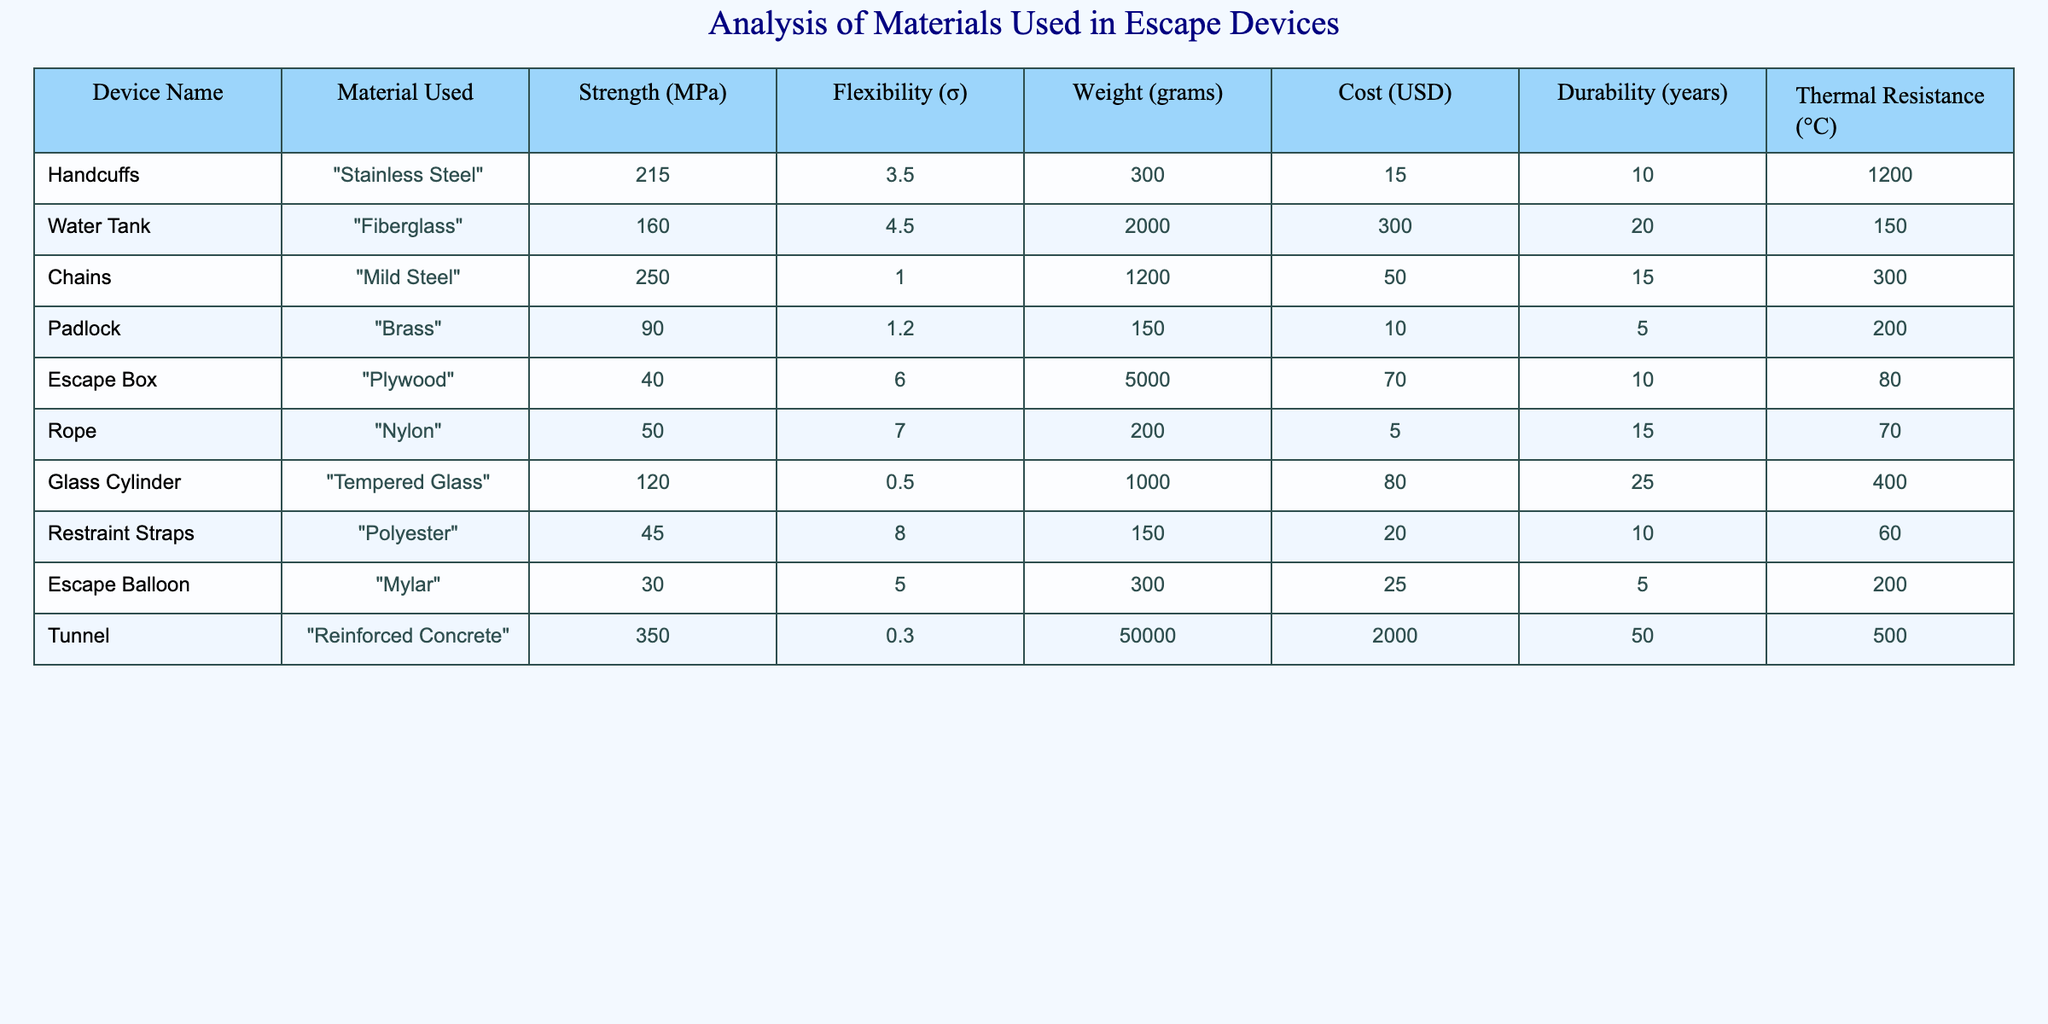What's the material used for the "Escape Balloon"? The table directly lists the material used for each device, and for the "Escape Balloon," it shows "Mylar."
Answer: Mylar Which device has the highest strength measured in MPa? By comparing the strength values listed in the table, the "Tunnel" has the highest strength at 350 MPa, more than any other device.
Answer: Tunnel What is the total weight of all the devices combined? The weights of all devices are summed: 300 + 2000 + 1200 + 150 + 5000 + 200 + 1000 + 150 + 300 + 50000 = 57700 grams.
Answer: 57700 grams Does "Stainless Steel" offer better thermal resistance than "Brass"? The thermal resistance for "Stainless Steel" is 1200 °C while for "Brass" it is only 200 °C, thus "Stainless Steel" is better.
Answer: Yes Which device has the lowest cost and what is that cost? Looking at the cost column, the "Rope" is listed as the least expensive at 5 USD.
Answer: 5 USD What is the average durability of all escape devices? To find the average durability, sum the durability values: (10 + 20 + 15 + 5 + 10 + 15 + 25 + 10 + 5 + 50) = 120. Then divide by the number of devices (10): 120 / 10 = 12.
Answer: 12 years Is the weight of the "Glass Cylinder" more than that of the "Padlock"? The weight of the "Glass Cylinder" is 1000 grams, while the "Padlock" weighs only 150 grams. Thus, the statement is true.
Answer: Yes What material is used in most devices, and how many devices use it? On examining the table, the material used most frequently is "Steel" (Mild Steel), which is used in 1 device (Chains).
Answer: Mild Steel, 1 device Which escape device has the least flexibility? The device with the least flexibility, indicated by its σ value, is the "Tunnel" with a flexibility of 0.3.
Answer: Tunnel What is the cost difference between the "Water Tank" and the "Escape Box"? Subtract the cost of the "Escape Box" (70 USD) from the "Water Tank" (300 USD): 300 - 70 = 230 USD difference.
Answer: 230 USD 